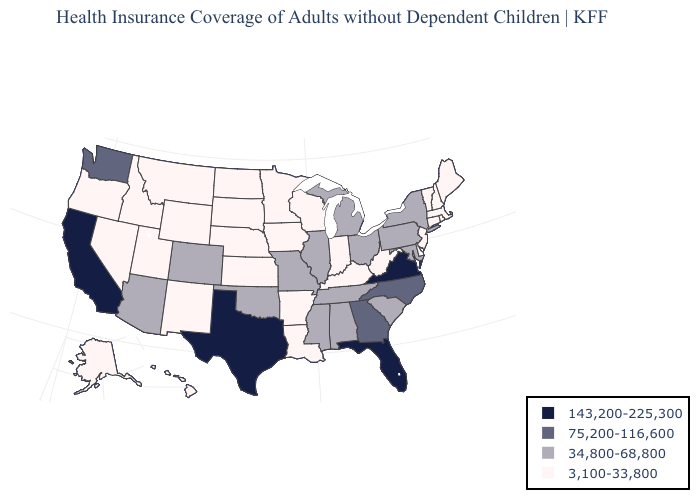Does Michigan have the highest value in the MidWest?
Short answer required. Yes. What is the value of Colorado?
Write a very short answer. 34,800-68,800. What is the lowest value in states that border Florida?
Short answer required. 34,800-68,800. What is the value of Missouri?
Short answer required. 34,800-68,800. Among the states that border Washington , which have the highest value?
Write a very short answer. Idaho, Oregon. What is the value of Oregon?
Keep it brief. 3,100-33,800. Which states have the lowest value in the USA?
Concise answer only. Alaska, Arkansas, Connecticut, Delaware, Hawaii, Idaho, Indiana, Iowa, Kansas, Kentucky, Louisiana, Maine, Massachusetts, Minnesota, Montana, Nebraska, Nevada, New Hampshire, New Jersey, New Mexico, North Dakota, Oregon, Rhode Island, South Dakota, Utah, Vermont, West Virginia, Wisconsin, Wyoming. What is the value of Montana?
Keep it brief. 3,100-33,800. Among the states that border North Carolina , does Virginia have the highest value?
Short answer required. Yes. Does Florida have the highest value in the USA?
Keep it brief. Yes. Name the states that have a value in the range 75,200-116,600?
Be succinct. Georgia, North Carolina, Washington. Name the states that have a value in the range 143,200-225,300?
Be succinct. California, Florida, Texas, Virginia. How many symbols are there in the legend?
Quick response, please. 4. Name the states that have a value in the range 3,100-33,800?
Quick response, please. Alaska, Arkansas, Connecticut, Delaware, Hawaii, Idaho, Indiana, Iowa, Kansas, Kentucky, Louisiana, Maine, Massachusetts, Minnesota, Montana, Nebraska, Nevada, New Hampshire, New Jersey, New Mexico, North Dakota, Oregon, Rhode Island, South Dakota, Utah, Vermont, West Virginia, Wisconsin, Wyoming. Does Arizona have the lowest value in the West?
Give a very brief answer. No. 